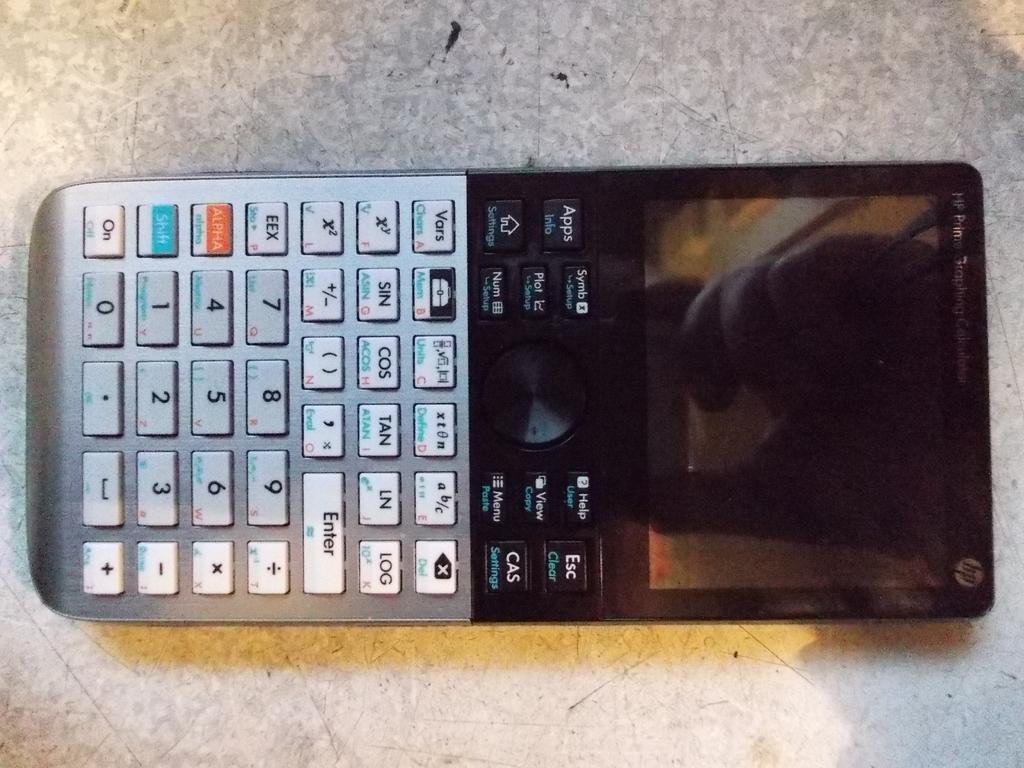<image>
Relay a brief, clear account of the picture shown. An HP prime graphing calculator laying on a tile surface 